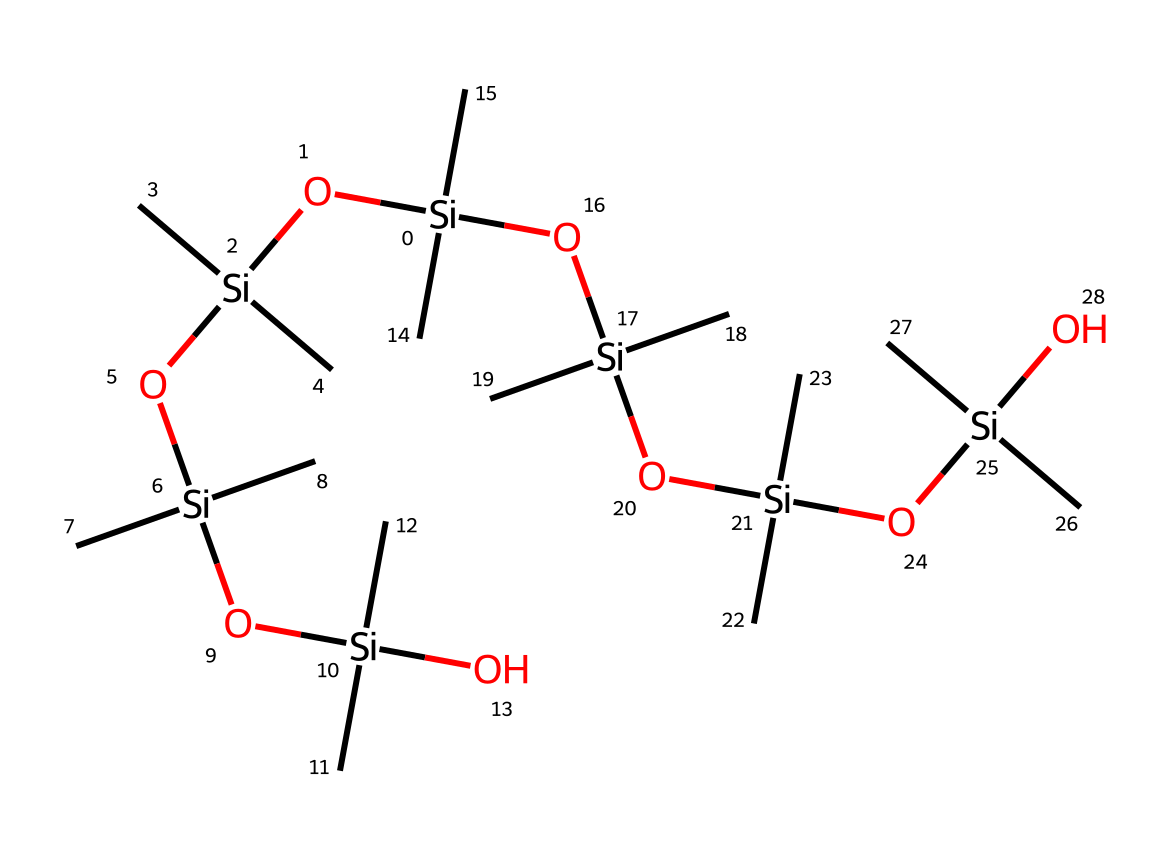What is the central atom in the structure? The structure features silicon as the primary element, which can be identified by its central position and the significant number of attached oxygen and carbon groups.
Answer: silicon How many silicon atoms are in this chemical structure? By analyzing the given SMILES representation, we can count six distinct silicon atoms present, which are linked in a chain with various functional groups.
Answer: six What type of bond is primarily formed between silicon and oxygen in this compound? The silicone structure typically exhibits covalent bonding, where silicon atoms form strong bonds with oxygen atoms, indicating the stability and durability of the material.
Answer: covalent What is the significance of the branching alkyl groups around silicon? The presence of branching alkyl groups on each silicon contributes to the hydrophobic and durable characteristics of the silicone coating, enhancing the coating's performance against wear.
Answer: hydrophobic How does the presence of oxygen atoms influence the durability of this coating? Oxygen atoms help provide a network of bonding and enhance chemical stability, which contributes significantly to the overall durability of the silicone-based coating.
Answer: chemical stability What type of organosilicon compound is represented in this structure? The presence of both alkyl groups and silanol groups points to it being a silicone polymer, specifically a type known for providing moisture resistance and flexibility in coatings.
Answer: silicone polymer What property do the multiple silanol groups impart to this coating? The multiple silanol groups can contribute to increased adhesion and flexibility of the coating, making it more durable and effective as a protective layer on office furniture.
Answer: adhesion 